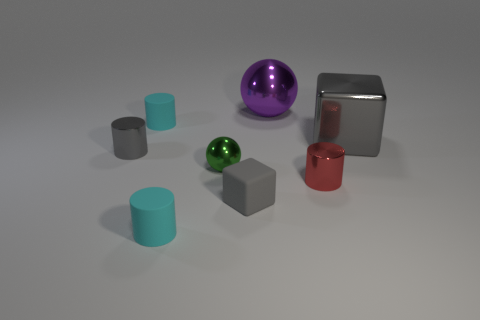Subtract all blue blocks. Subtract all red balls. How many blocks are left? 2 Add 1 small red metallic cylinders. How many objects exist? 9 Subtract all spheres. How many objects are left? 6 Subtract 0 yellow cylinders. How many objects are left? 8 Subtract all red shiny cylinders. Subtract all tiny red things. How many objects are left? 6 Add 3 small metallic spheres. How many small metallic spheres are left? 4 Add 7 cyan matte things. How many cyan matte things exist? 9 